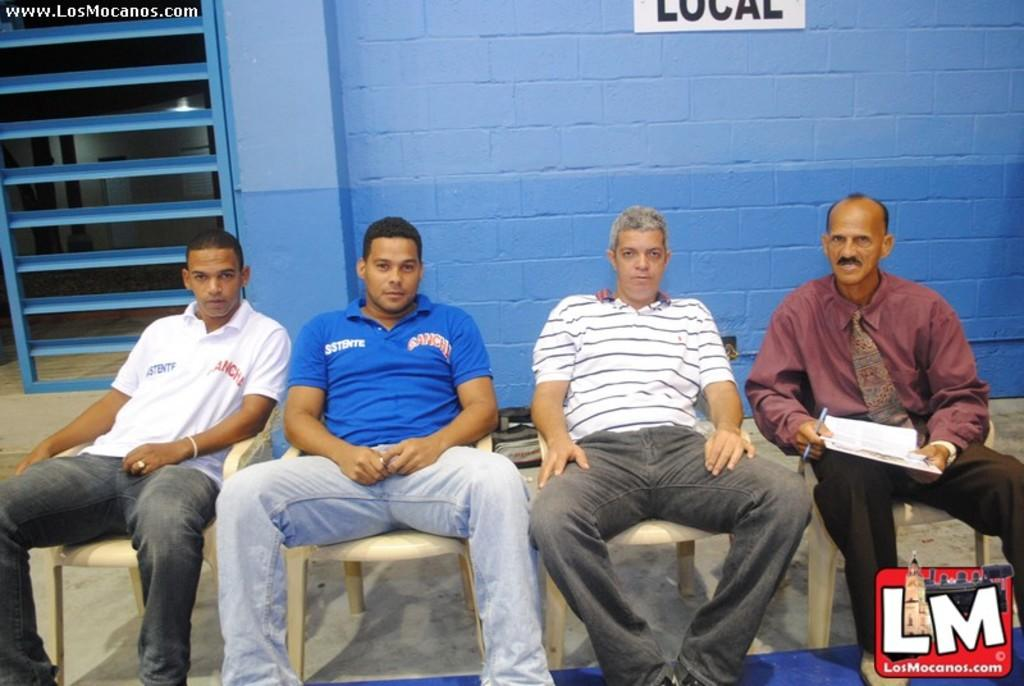How many people are present in the image? There are four people in the image. What are the people doing in the image? The people are sitting on chairs. What can be seen in the background of the image? There is a wall in the background of the image. What type of protest is happening in the image? There is no protest present in the image; it features four people sitting on chairs. What kind of breakfast is being served in the image? There is no breakfast present in the image; it only shows four people sitting on chairs. 